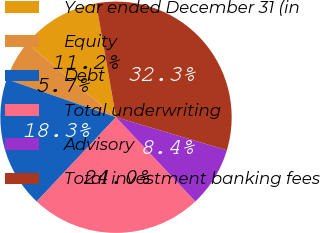Convert chart to OTSL. <chart><loc_0><loc_0><loc_500><loc_500><pie_chart><fcel>Year ended December 31 (in<fcel>Equity<fcel>Debt<fcel>Total underwriting<fcel>Advisory<fcel>Total investment banking fees<nl><fcel>11.21%<fcel>5.71%<fcel>18.32%<fcel>24.04%<fcel>8.38%<fcel>32.35%<nl></chart> 